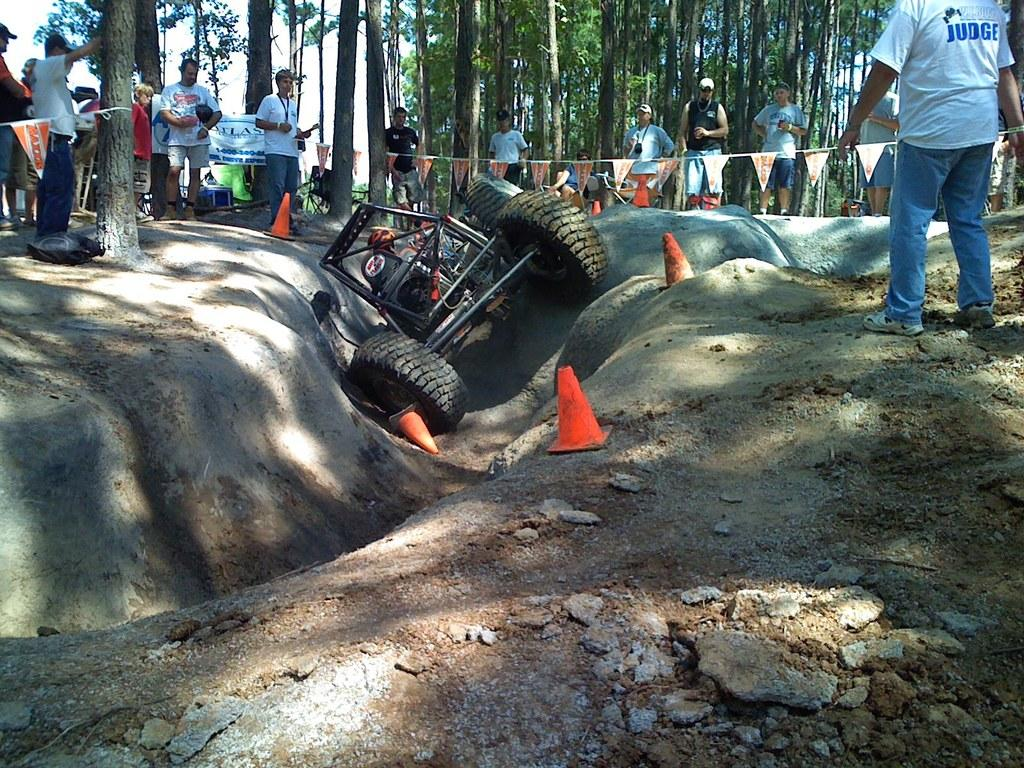What is the main subject of the image? The main subject of the image is a vehicle that is stuck. What are the people in the image doing? The people in the image are standing around the vehicle. What can be seen in the background of the image? There are trees visible in the backdrop of the image. How would you describe the weather in the image? The sky is clear in the image, suggesting good weather. Can you see a swing in the image? No, there is no swing present in the image. Is the vehicle stuck on an island in the image? No, the image does not depict an island; it shows a vehicle stuck with trees in the background. 